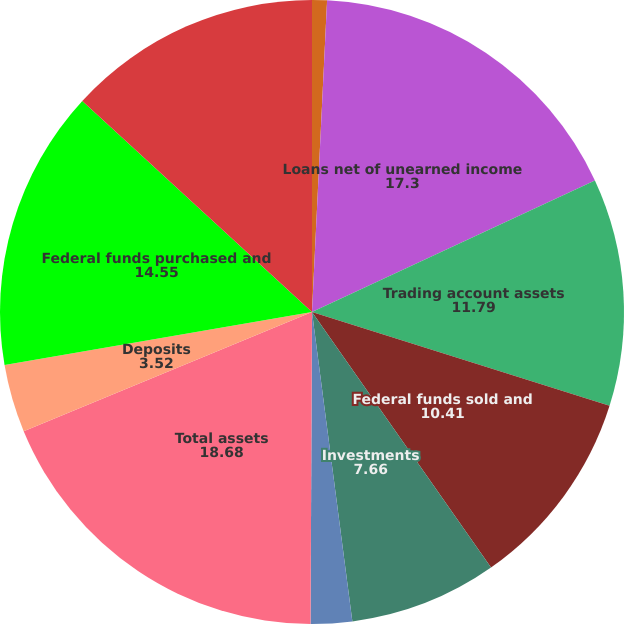<chart> <loc_0><loc_0><loc_500><loc_500><pie_chart><fcel>Cash and deposits with banks<fcel>Loans net of unearned income<fcel>Trading account assets<fcel>Federal funds sold and<fcel>Investments<fcel>Other assets<fcel>Total assets<fcel>Deposits<fcel>Federal funds purchased and<fcel>Short-term borrowings and<nl><fcel>0.77%<fcel>17.3%<fcel>11.79%<fcel>10.41%<fcel>7.66%<fcel>2.14%<fcel>18.68%<fcel>3.52%<fcel>14.55%<fcel>13.17%<nl></chart> 